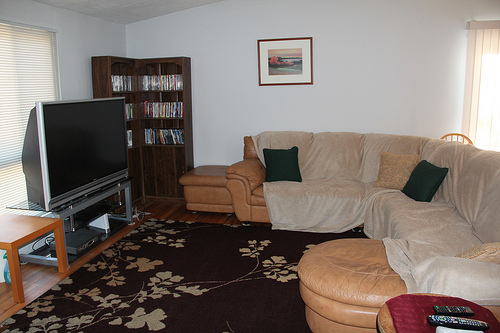Can you describe the artwork on the wall? This image captures a modest-sized framed artwork hanging on the wall above the bookcase. Its landscape painting adds a serene aesthetic to the room. 